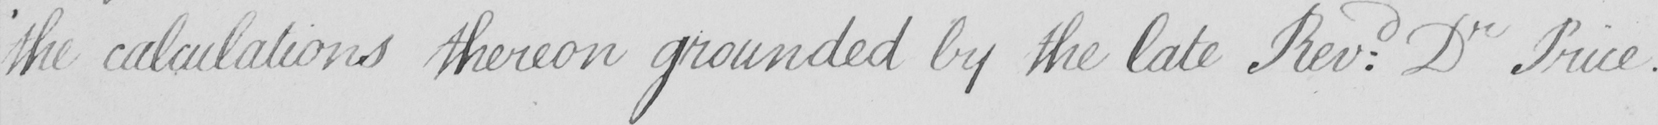What is written in this line of handwriting? ' the calculations thereon grounded by the late Rev : d Dr Price . 